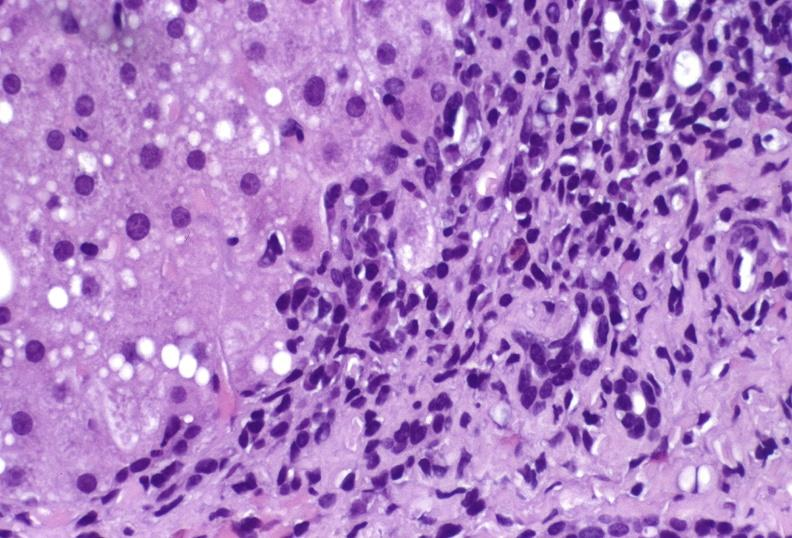does this image show hepatitis c virus?
Answer the question using a single word or phrase. Yes 